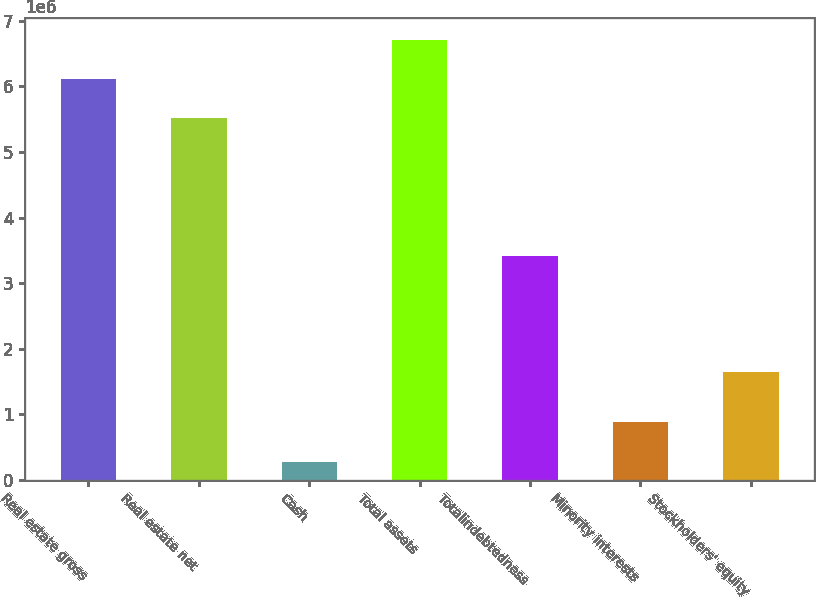<chart> <loc_0><loc_0><loc_500><loc_500><bar_chart><fcel>Real estate gross<fcel>Real estate net<fcel>Cash<fcel>Total assets<fcel>Totalindebtedness<fcel>Minority interests<fcel>Stockholders' equity<nl><fcel>6.12061e+06<fcel>5.52606e+06<fcel>280957<fcel>6.71516e+06<fcel>3.41489e+06<fcel>877715<fcel>1.64773e+06<nl></chart> 